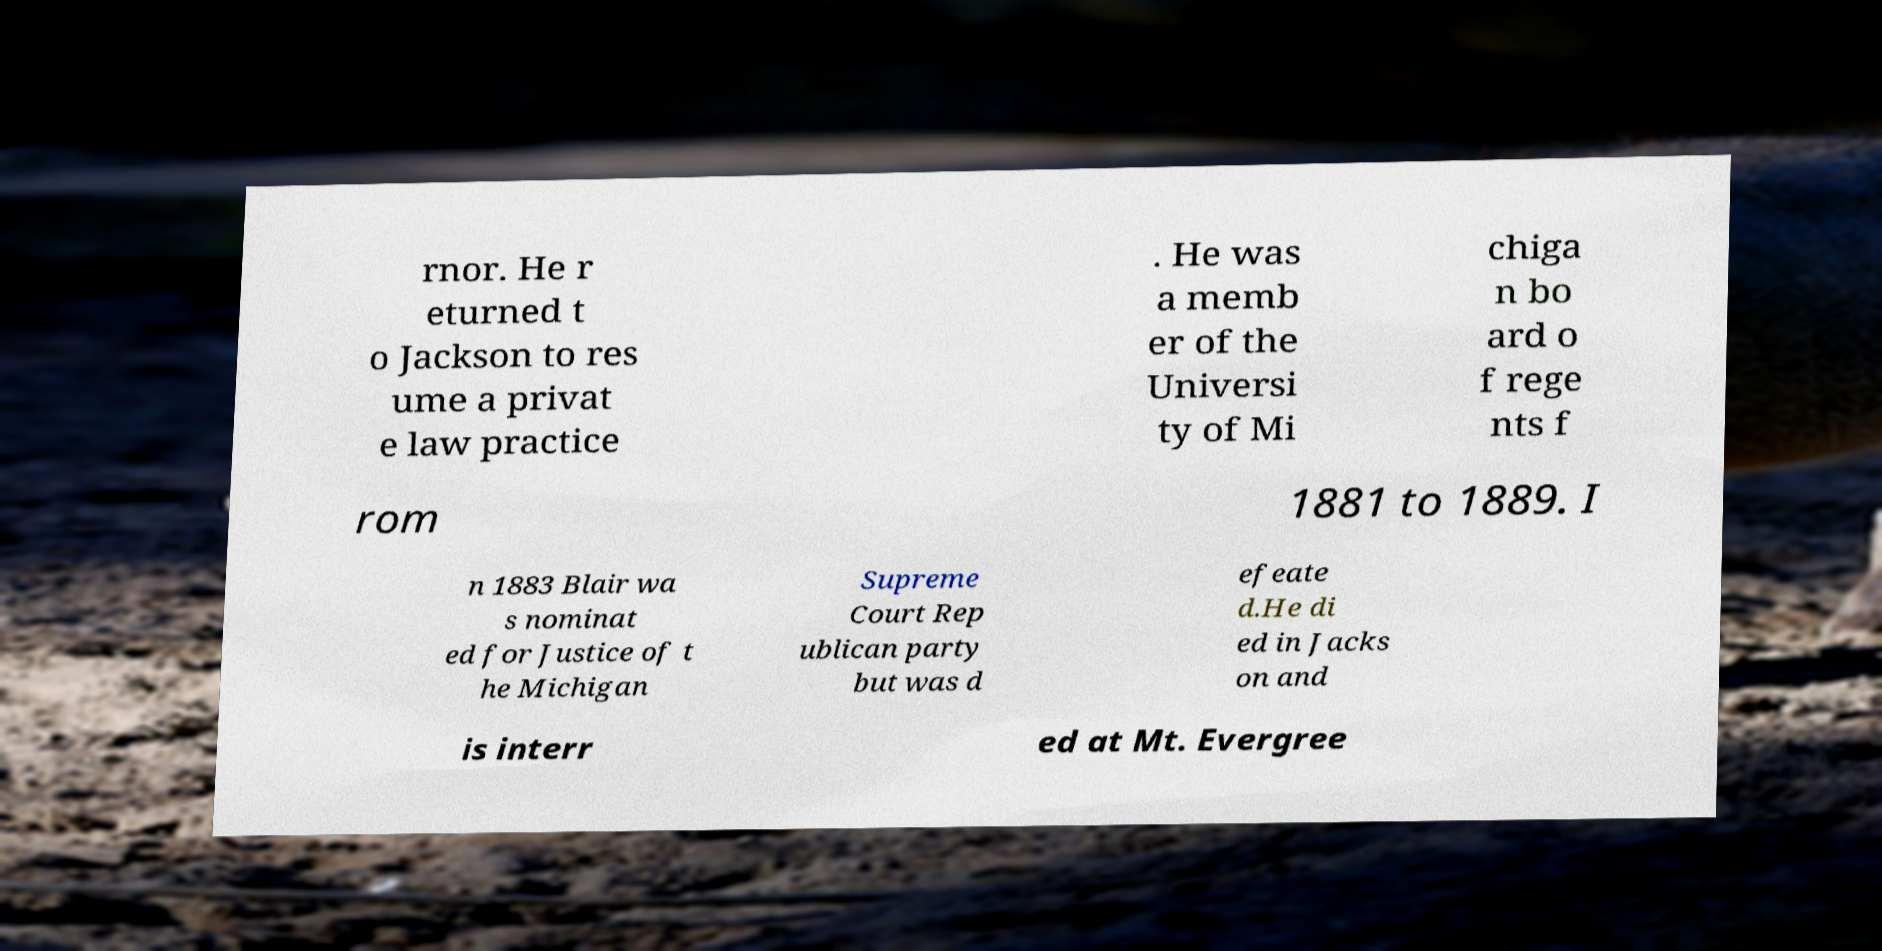I need the written content from this picture converted into text. Can you do that? rnor. He r eturned t o Jackson to res ume a privat e law practice . He was a memb er of the Universi ty of Mi chiga n bo ard o f rege nts f rom 1881 to 1889. I n 1883 Blair wa s nominat ed for Justice of t he Michigan Supreme Court Rep ublican party but was d efeate d.He di ed in Jacks on and is interr ed at Mt. Evergree 